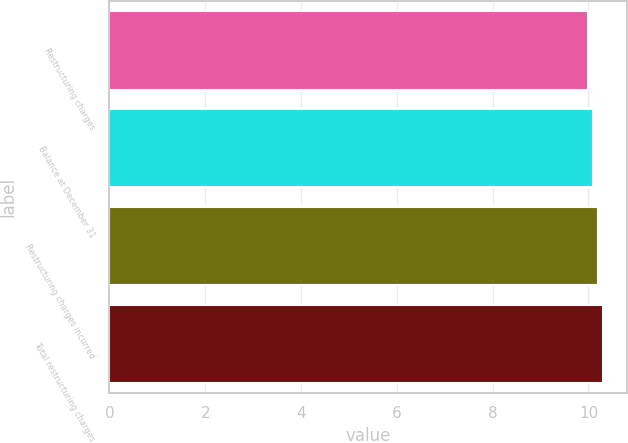<chart> <loc_0><loc_0><loc_500><loc_500><bar_chart><fcel>Restructuring charges<fcel>Balance at December 31<fcel>Restructuring charges incurred<fcel>Total restructuring charges<nl><fcel>10<fcel>10.1<fcel>10.2<fcel>10.3<nl></chart> 